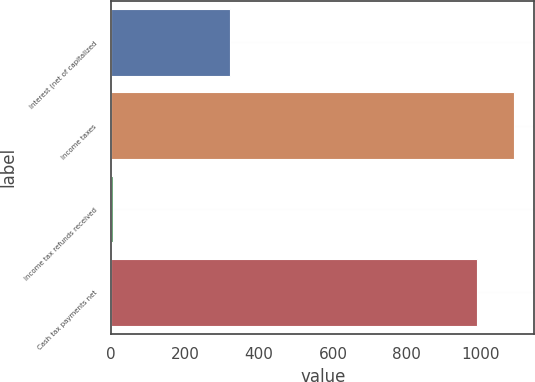Convert chart to OTSL. <chart><loc_0><loc_0><loc_500><loc_500><bar_chart><fcel>Interest (net of capitalized<fcel>Income taxes<fcel>Income tax refunds received<fcel>Cash tax payments net<nl><fcel>321<fcel>1090.1<fcel>5<fcel>991<nl></chart> 